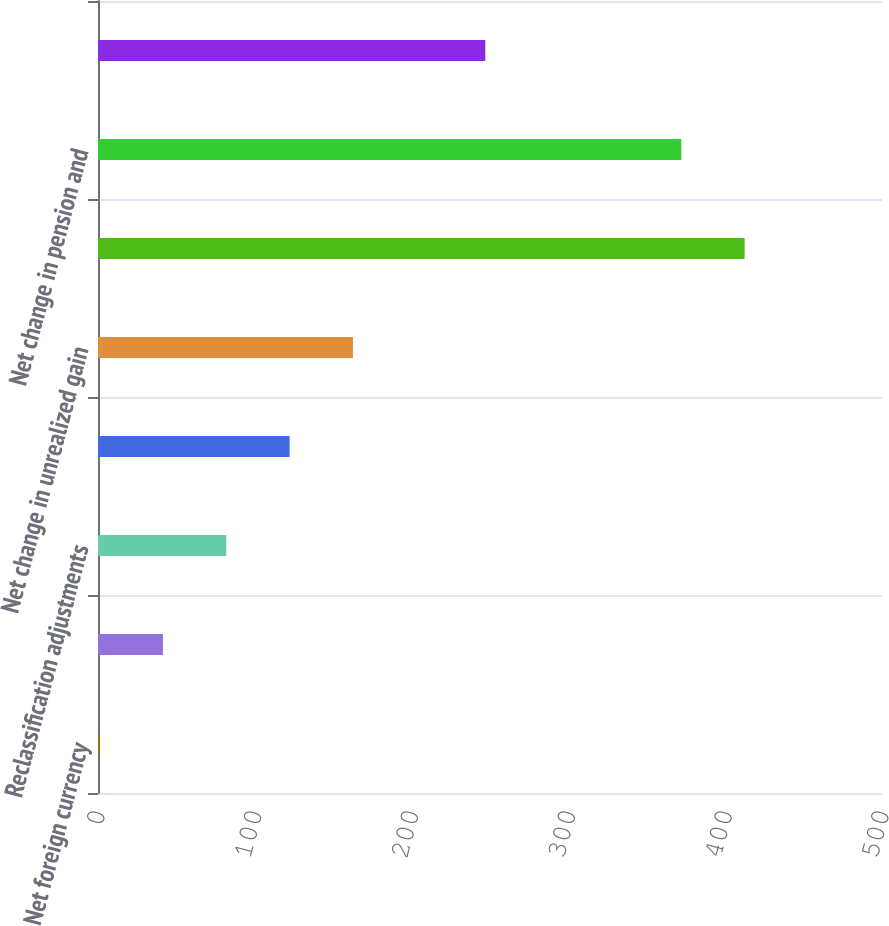<chart> <loc_0><loc_0><loc_500><loc_500><bar_chart><fcel>Net foreign currency<fcel>Unrealized gains (losses)<fcel>Reclassification adjustments<fcel>Net gain (loss) on derivatives<fcel>Net change in unrealized gain<fcel>Net pension and other benefits<fcel>Net change in pension and<fcel>Other comprehensive income<nl><fcel>1<fcel>41.4<fcel>81.8<fcel>122.2<fcel>162.6<fcel>412.4<fcel>372<fcel>247<nl></chart> 